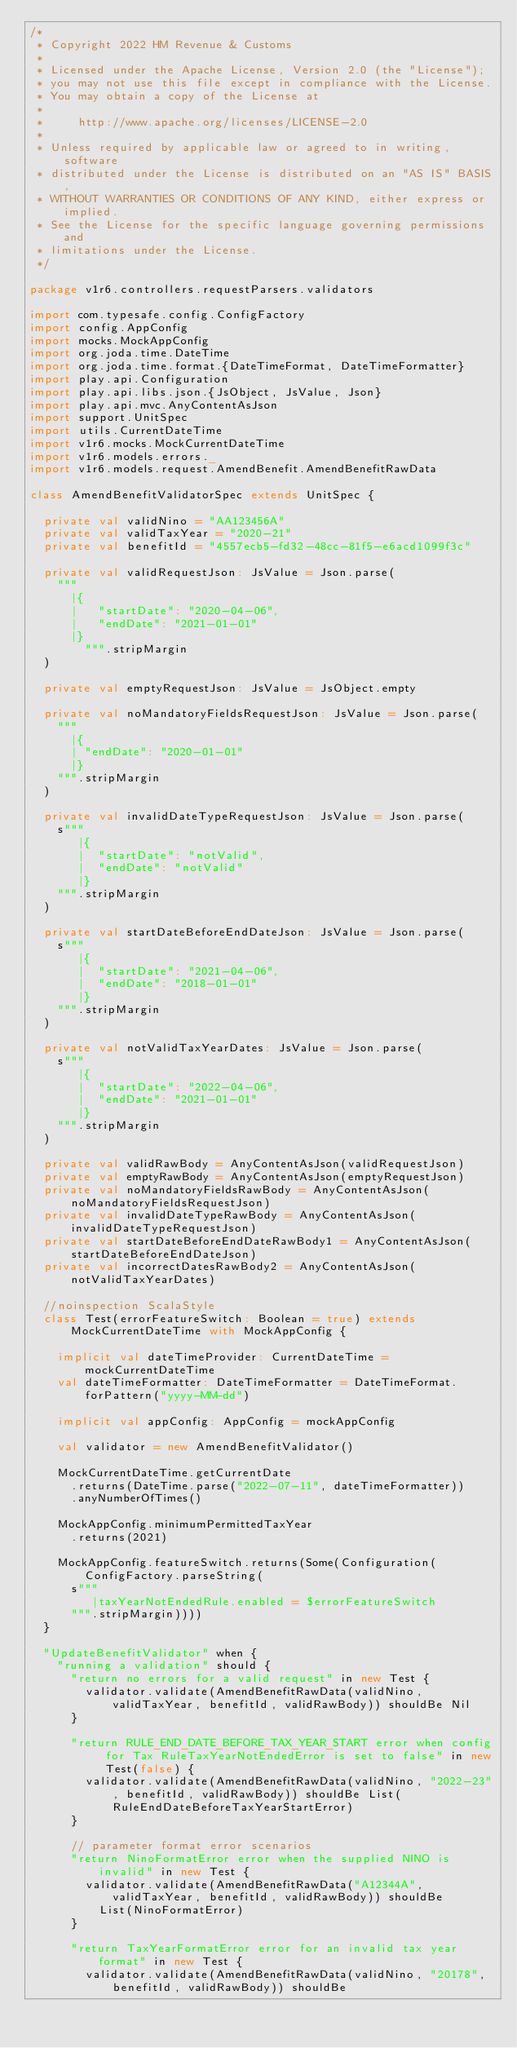<code> <loc_0><loc_0><loc_500><loc_500><_Scala_>/*
 * Copyright 2022 HM Revenue & Customs
 *
 * Licensed under the Apache License, Version 2.0 (the "License");
 * you may not use this file except in compliance with the License.
 * You may obtain a copy of the License at
 *
 *     http://www.apache.org/licenses/LICENSE-2.0
 *
 * Unless required by applicable law or agreed to in writing, software
 * distributed under the License is distributed on an "AS IS" BASIS,
 * WITHOUT WARRANTIES OR CONDITIONS OF ANY KIND, either express or implied.
 * See the License for the specific language governing permissions and
 * limitations under the License.
 */

package v1r6.controllers.requestParsers.validators

import com.typesafe.config.ConfigFactory
import config.AppConfig
import mocks.MockAppConfig
import org.joda.time.DateTime
import org.joda.time.format.{DateTimeFormat, DateTimeFormatter}
import play.api.Configuration
import play.api.libs.json.{JsObject, JsValue, Json}
import play.api.mvc.AnyContentAsJson
import support.UnitSpec
import utils.CurrentDateTime
import v1r6.mocks.MockCurrentDateTime
import v1r6.models.errors._
import v1r6.models.request.AmendBenefit.AmendBenefitRawData

class AmendBenefitValidatorSpec extends UnitSpec {

  private val validNino = "AA123456A"
  private val validTaxYear = "2020-21"
  private val benefitId = "4557ecb5-fd32-48cc-81f5-e6acd1099f3c"

  private val validRequestJson: JsValue = Json.parse(
    """
      |{
      |   "startDate": "2020-04-06",
      |   "endDate": "2021-01-01"
      |}
        """.stripMargin
  )

  private val emptyRequestJson: JsValue = JsObject.empty

  private val noMandatoryFieldsRequestJson: JsValue = Json.parse(
    """
      |{
      | "endDate": "2020-01-01"
      |}
    """.stripMargin
  )

  private val invalidDateTypeRequestJson: JsValue = Json.parse(
    s"""
       |{
       |  "startDate": "notValid",
       |  "endDate": "notValid"
       |}
    """.stripMargin
  )

  private val startDateBeforeEndDateJson: JsValue = Json.parse(
    s"""
       |{
       |  "startDate": "2021-04-06",
       |  "endDate": "2018-01-01"
       |}
    """.stripMargin
  )

  private val notValidTaxYearDates: JsValue = Json.parse(
    s"""
       |{
       |  "startDate": "2022-04-06",
       |  "endDate": "2021-01-01"
       |}
    """.stripMargin
  )

  private val validRawBody = AnyContentAsJson(validRequestJson)
  private val emptyRawBody = AnyContentAsJson(emptyRequestJson)
  private val noMandatoryFieldsRawBody = AnyContentAsJson(noMandatoryFieldsRequestJson)
  private val invalidDateTypeRawBody = AnyContentAsJson(invalidDateTypeRequestJson)
  private val startDateBeforeEndDateRawBody1 = AnyContentAsJson(startDateBeforeEndDateJson)
  private val incorrectDatesRawBody2 = AnyContentAsJson(notValidTaxYearDates)

  //noinspection ScalaStyle
  class Test(errorFeatureSwitch: Boolean = true) extends MockCurrentDateTime with MockAppConfig {

    implicit val dateTimeProvider: CurrentDateTime = mockCurrentDateTime
    val dateTimeFormatter: DateTimeFormatter = DateTimeFormat.forPattern("yyyy-MM-dd")

    implicit val appConfig: AppConfig = mockAppConfig

    val validator = new AmendBenefitValidator()

    MockCurrentDateTime.getCurrentDate
      .returns(DateTime.parse("2022-07-11", dateTimeFormatter))
      .anyNumberOfTimes()

    MockAppConfig.minimumPermittedTaxYear
      .returns(2021)

    MockAppConfig.featureSwitch.returns(Some(Configuration(ConfigFactory.parseString(
      s"""
         |taxYearNotEndedRule.enabled = $errorFeatureSwitch
      """.stripMargin))))
  }

  "UpdateBenefitValidator" when {
    "running a validation" should {
      "return no errors for a valid request" in new Test {
        validator.validate(AmendBenefitRawData(validNino, validTaxYear, benefitId, validRawBody)) shouldBe Nil
      }

      "return RULE_END_DATE_BEFORE_TAX_YEAR_START error when config for Tax RuleTaxYearNotEndedError is set to false" in new Test(false) {
        validator.validate(AmendBenefitRawData(validNino, "2022-23", benefitId, validRawBody)) shouldBe List(RuleEndDateBeforeTaxYearStartError)
      }

      // parameter format error scenarios
      "return NinoFormatError error when the supplied NINO is invalid" in new Test {
        validator.validate(AmendBenefitRawData("A12344A", validTaxYear, benefitId, validRawBody)) shouldBe
          List(NinoFormatError)
      }

      "return TaxYearFormatError error for an invalid tax year format" in new Test {
        validator.validate(AmendBenefitRawData(validNino, "20178", benefitId, validRawBody)) shouldBe</code> 